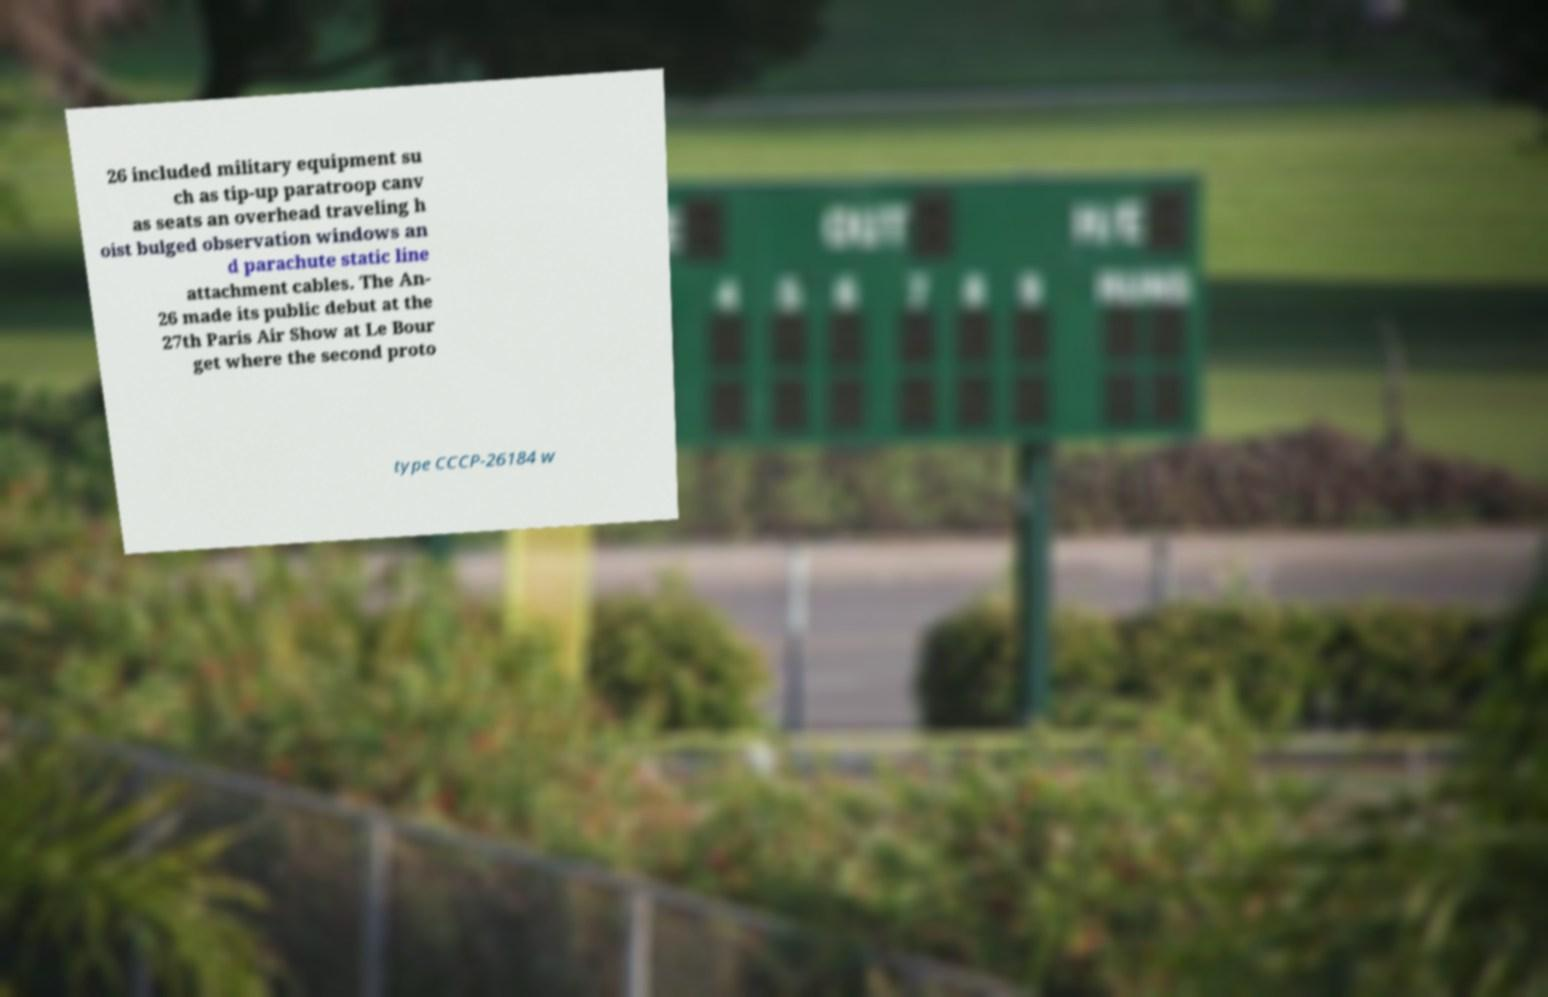What messages or text are displayed in this image? I need them in a readable, typed format. 26 included military equipment su ch as tip-up paratroop canv as seats an overhead traveling h oist bulged observation windows an d parachute static line attachment cables. The An- 26 made its public debut at the 27th Paris Air Show at Le Bour get where the second proto type CCCP-26184 w 